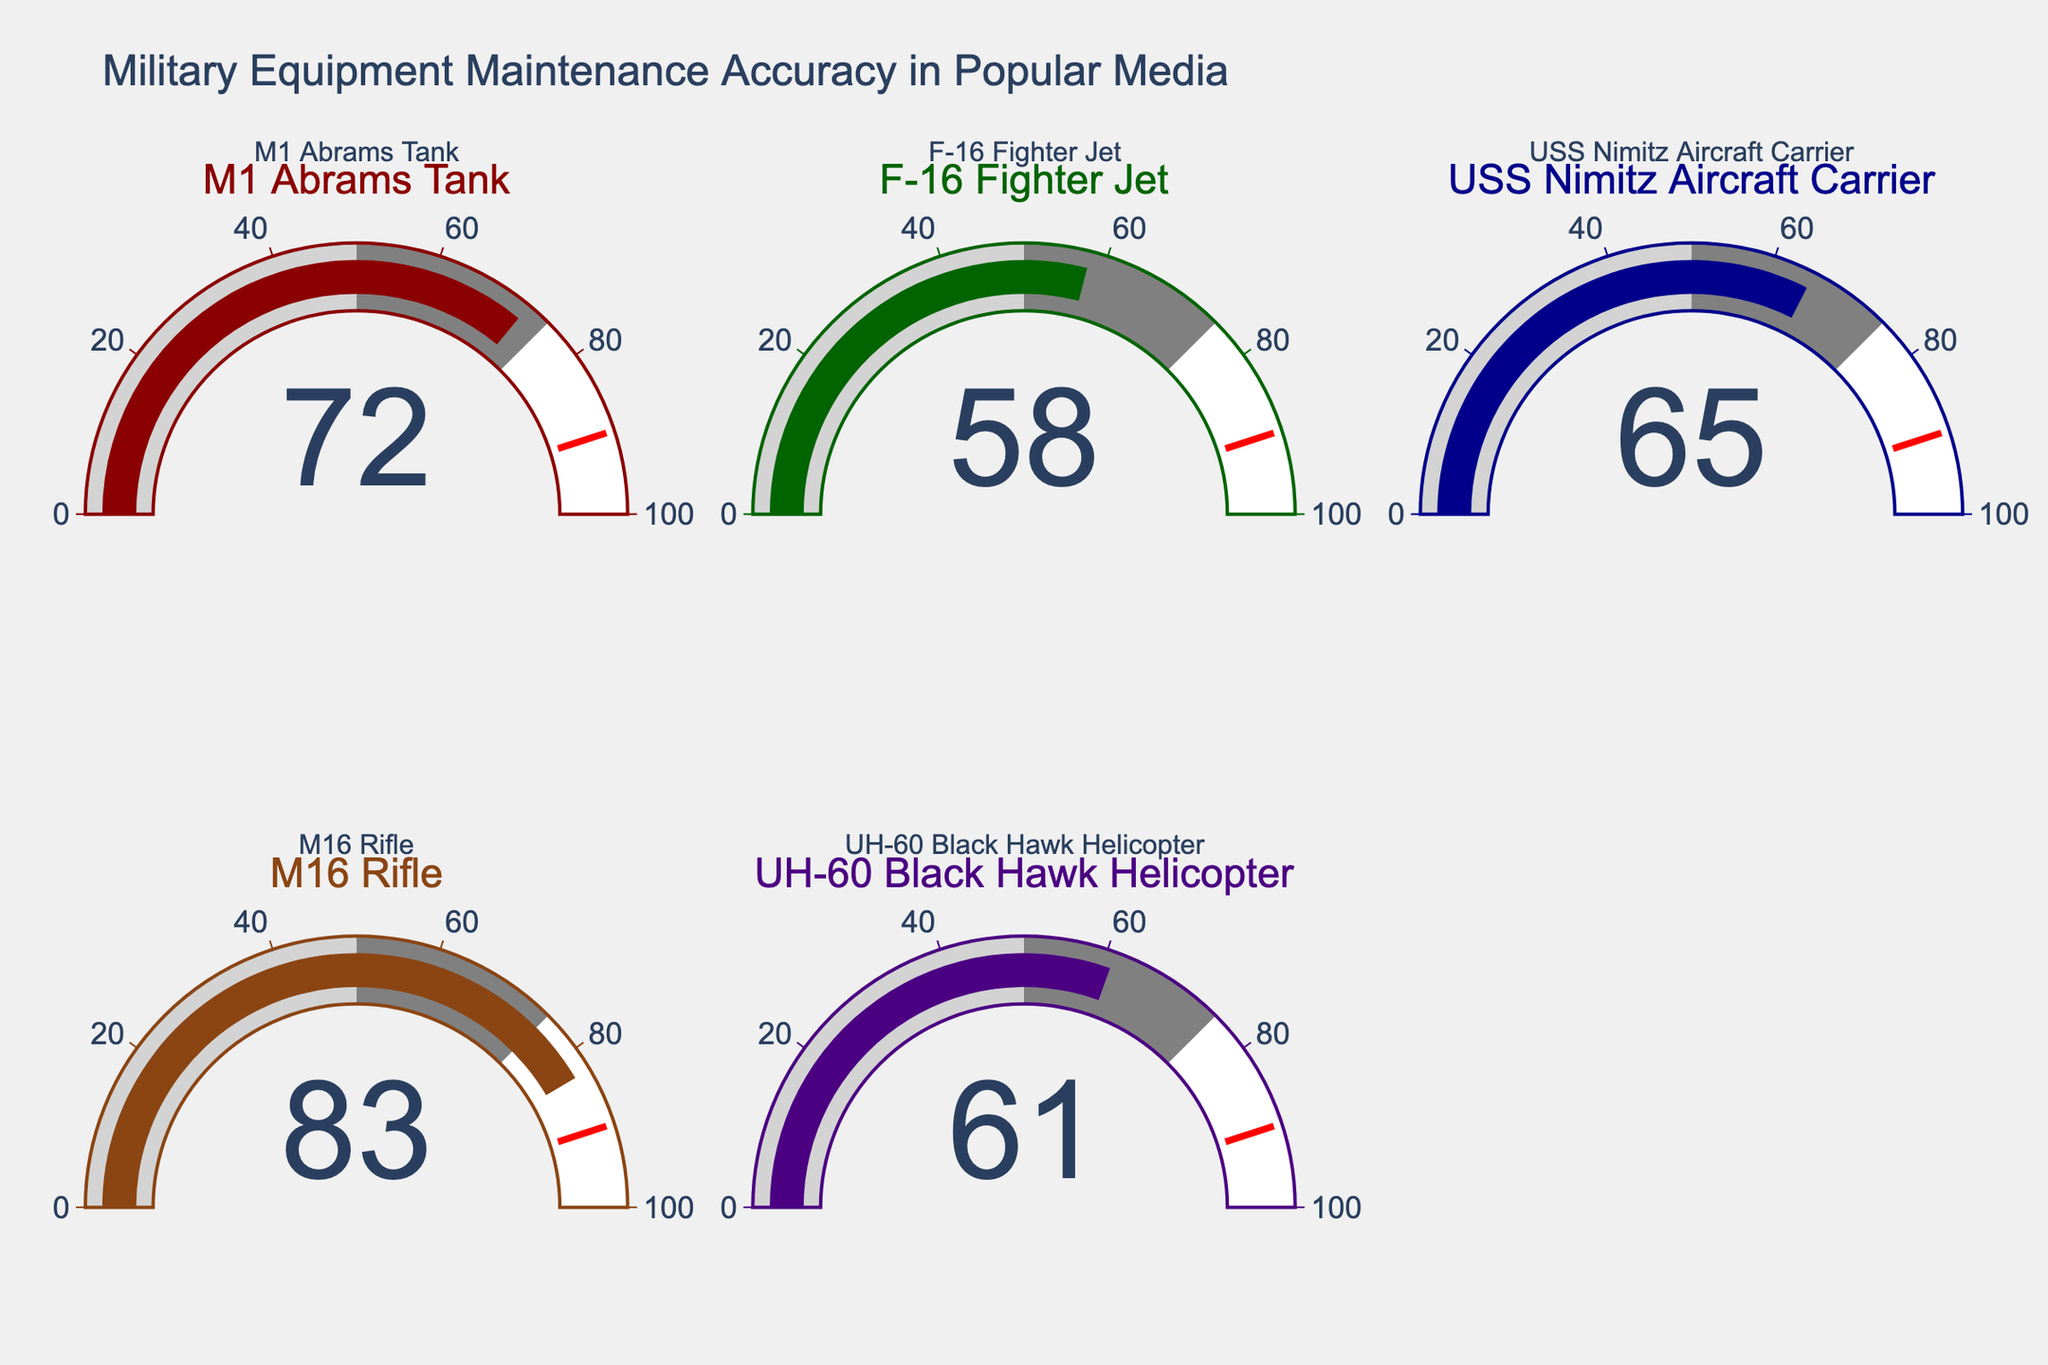What is the title of the figure? The title of the figure is usually the most prominent text and located at the top. In the provided plot, the title reads "Military Equipment Maintenance Accuracy in Popular Media."
Answer: Military Equipment Maintenance Accuracy in Popular Media Which category has the highest accuracy percentage? The gauge chart for each category displays a percentage, with the M16 Rifle showing the highest value at 83%.
Answer: M16 Rifle Which category has the lowest accuracy percentage? By examining the gauge charts, the F-16 Fighter Jet has the lowest percentage at 58%.
Answer: F-16 Fighter Jet What is the total sum of the accuracy percentages across all categories? By adding up each accuracy value: 72 (M1 Abrams Tank) + 58 (F-16 Fighter Jet) + 65 (USS Nimitz Aircraft Carrier) + 83 (M16 Rifle) + 61 (UH-60 Black Hawk Helicopter), the total sum is 339.
Answer: 339 What is the average accuracy percentage across all depicted categories? First, calculate the sum of all percentages: 72 + 58 + 65 + 83 + 61 = 339. Then, divide by the number of categories, which is 5. Thus, the average is 339 / 5 = 67.8.
Answer: 67.8 Which two categories have the closest accuracy percentages, and what are their values? Comparing the accuracy percentages: the UH-60 Black Hawk Helicopter (61%) and USS Nimitz Aircraft Carrier (65%) are closest to each other with a difference of just 4 percentage points.
Answer: UH-60 Black Hawk Helicopter (61%) and USS Nimitz Aircraft Carrier (65%) How many categories have an accuracy percentage above 60%? By counting the categories with an accuracy percentage above 60%: M1 Abrams Tank (72%), USS Nimitz Aircraft Carrier (65%), M16 Rifle (83%), and UH-60 Black Hawk Helicopter (61%), there are four categories.
Answer: 4 Which category is represented with the color green? Observing the colors used for each category, the M1 Abrams Tank is depicted with the green color.
Answer: M1 Abrams Tank How much higher is the accuracy percentage for the M16 Rifle compared to the F-16 Fighter Jet? The accuracy percentage for the M16 Rifle is 83%, and for the F-16 Fighter Jet, it is 58%. The difference can be calculated as 83 - 58 = 25.
Answer: 25 What is the combined accuracy percentage for the M1 Abrams Tank and the M16 Rifle? Adding the percentages for both categories: 72% (M1 Abrams Tank) + 83% (M16 Rifle) yields a total of 155%.
Answer: 155 